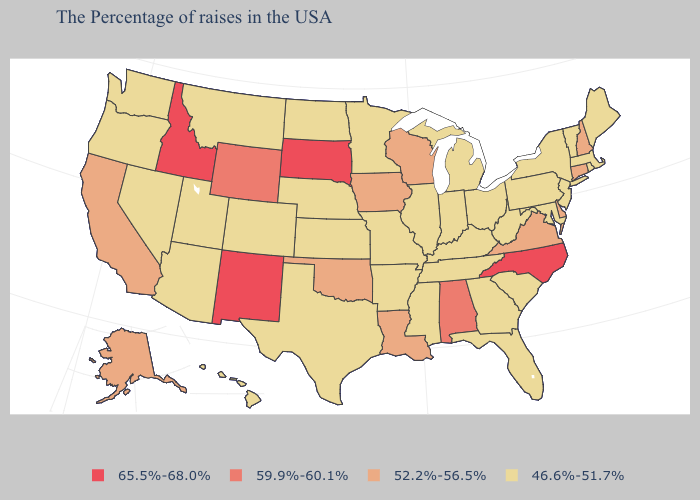Does North Dakota have a lower value than Indiana?
Short answer required. No. Among the states that border Arkansas , does Louisiana have the highest value?
Keep it brief. Yes. What is the lowest value in states that border North Carolina?
Be succinct. 46.6%-51.7%. What is the value of Oregon?
Keep it brief. 46.6%-51.7%. Which states have the lowest value in the South?
Write a very short answer. Maryland, South Carolina, West Virginia, Florida, Georgia, Kentucky, Tennessee, Mississippi, Arkansas, Texas. What is the value of Virginia?
Write a very short answer. 52.2%-56.5%. What is the value of South Carolina?
Give a very brief answer. 46.6%-51.7%. What is the lowest value in the USA?
Keep it brief. 46.6%-51.7%. Name the states that have a value in the range 46.6%-51.7%?
Write a very short answer. Maine, Massachusetts, Rhode Island, Vermont, New York, New Jersey, Maryland, Pennsylvania, South Carolina, West Virginia, Ohio, Florida, Georgia, Michigan, Kentucky, Indiana, Tennessee, Illinois, Mississippi, Missouri, Arkansas, Minnesota, Kansas, Nebraska, Texas, North Dakota, Colorado, Utah, Montana, Arizona, Nevada, Washington, Oregon, Hawaii. Does the map have missing data?
Answer briefly. No. Among the states that border Arkansas , does Oklahoma have the highest value?
Short answer required. Yes. Which states have the lowest value in the Northeast?
Answer briefly. Maine, Massachusetts, Rhode Island, Vermont, New York, New Jersey, Pennsylvania. What is the value of New York?
Give a very brief answer. 46.6%-51.7%. How many symbols are there in the legend?
Give a very brief answer. 4. 